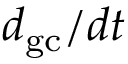<formula> <loc_0><loc_0><loc_500><loc_500>d _ { g c } / d t</formula> 